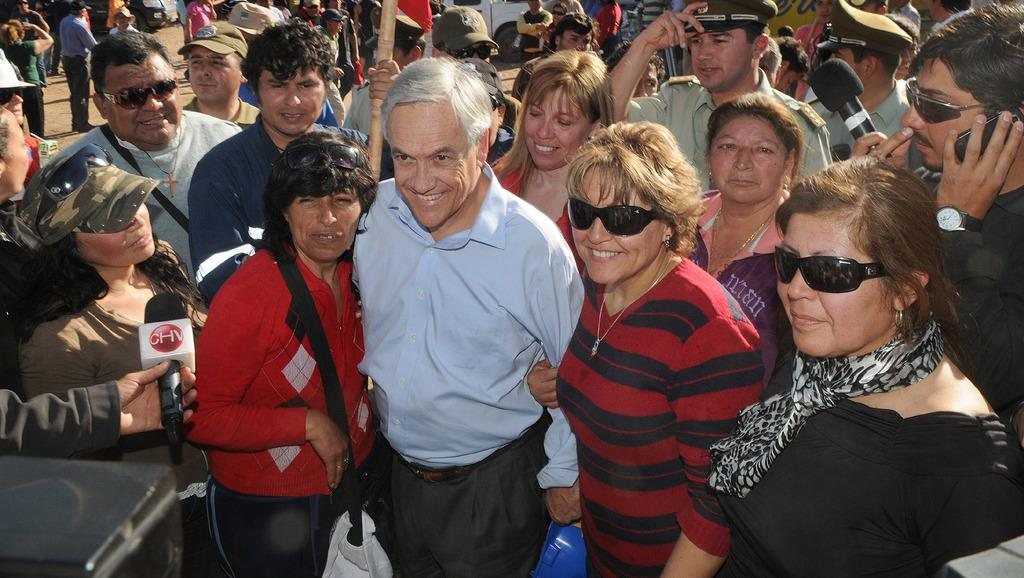What is happening on the road in the image? There are people on the road in the image. Can you describe what the people are doing? Two of the people are holding microphones. What type of furniture can be seen in the image? There is no furniture present in the image; it features people on the road holding microphones. 